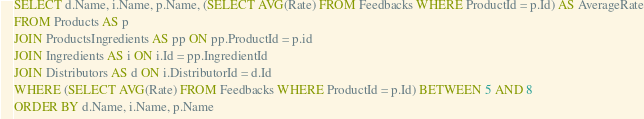Convert code to text. <code><loc_0><loc_0><loc_500><loc_500><_SQL_>SELECT d.Name, i.Name, p.Name, (SELECT AVG(Rate) FROM Feedbacks WHERE ProductId = p.Id) AS AverageRate
FROM Products AS p
JOIN ProductsIngredients AS pp ON pp.ProductId = p.id
JOIN Ingredients AS i ON i.Id = pp.IngredientId
JOIN Distributors AS d ON i.DistributorId = d.Id
WHERE (SELECT AVG(Rate) FROM Feedbacks WHERE ProductId = p.Id) BETWEEN 5 AND 8
ORDER BY d.Name, i.Name, p.Name
</code> 